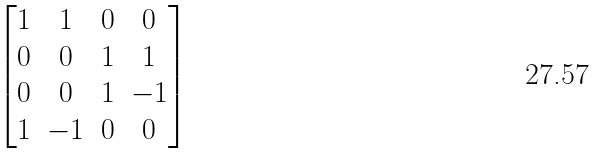<formula> <loc_0><loc_0><loc_500><loc_500>\begin{bmatrix} 1 & { 1 } & 0 & 0 \\ 0 & 0 & 1 & 1 \\ 0 & 0 & { 1 } & { - 1 } \\ 1 & { - 1 } & 0 & 0 \end{bmatrix}</formula> 